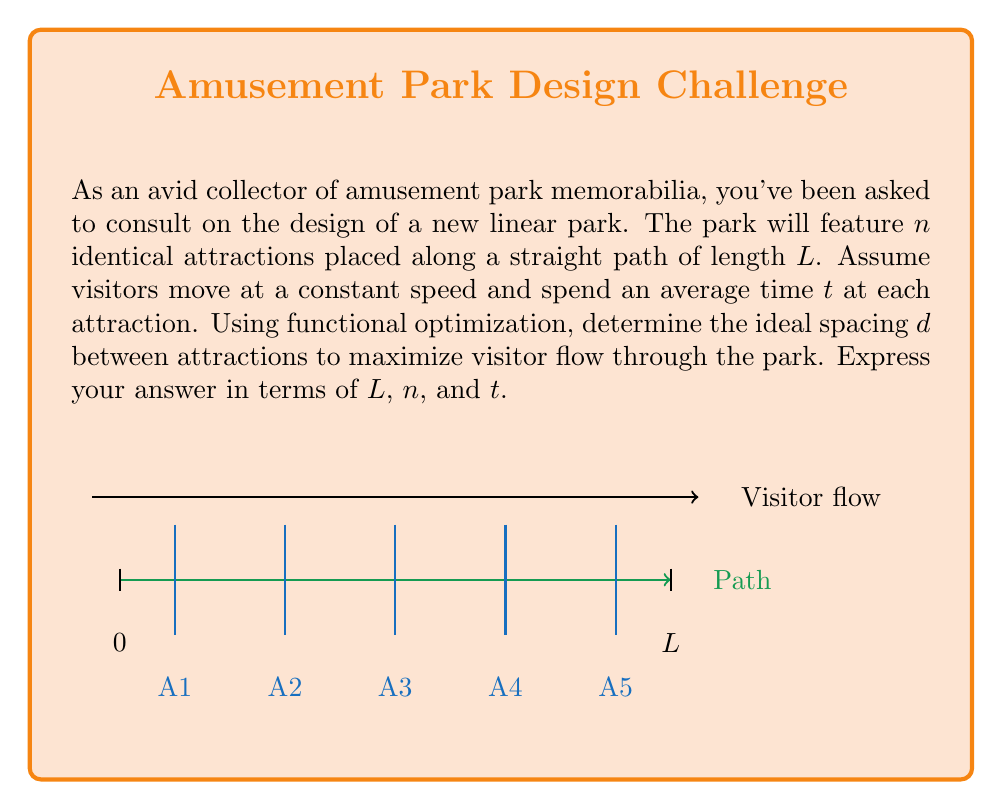Can you answer this question? Let's approach this step-by-step:

1) First, we need to set up our optimization problem. The total time T a visitor spends in the park is the sum of the time spent at attractions and the time spent walking between them:

   $$T = nt + \frac{L-d(n-1)}{v}$$

   where v is the visitor's walking speed.

2) The visitor flow rate F is inversely proportional to T:

   $$F = \frac{1}{T} = \frac{1}{nt + \frac{L-d(n-1)}{v}}$$

3) To maximize F, we need to minimize T. Let's consider T as a function of d:

   $$T(d) = nt + \frac{L-d(n-1)}{v}$$

4) To find the minimum, we differentiate T with respect to d and set it to zero:

   $$\frac{dT}{dd} = -\frac{n-1}{v} = 0$$

5) This equation is always true for any d, which means that T is a linear function of d and has no local minimum or maximum.

6) Since there's no local optimum, the optimal solution must be at one of the boundaries. We have two boundary conditions:
   - Minimum spacing: d = 0 (all attractions clustered at one end)
   - Maximum spacing: d = L/(n-1) (attractions evenly spaced)

7) Let's compare these two cases:
   - For d = 0: $$T_1 = nt + \frac{L}{v}$$
   - For d = L/(n-1): $$T_2 = nt + \frac{L-L}{v} = nt$$

8) Clearly, T_2 < T_1, so the maximum visitor flow is achieved when the attractions are evenly spaced.

Therefore, the ideal spacing is:

$$d = \frac{L}{n-1}$$
Answer: $$\frac{L}{n-1}$$ 